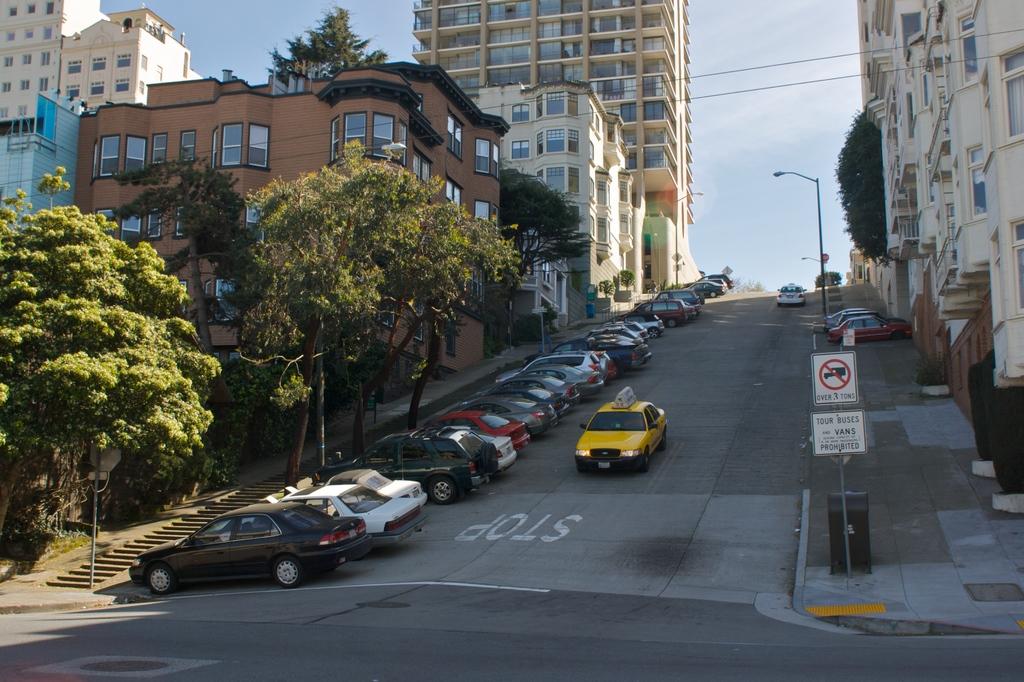What is written in white on the road that the taxi is approaching?
Provide a short and direct response. Stop. Is there a sign for tour buses?
Keep it short and to the point. Yes. 